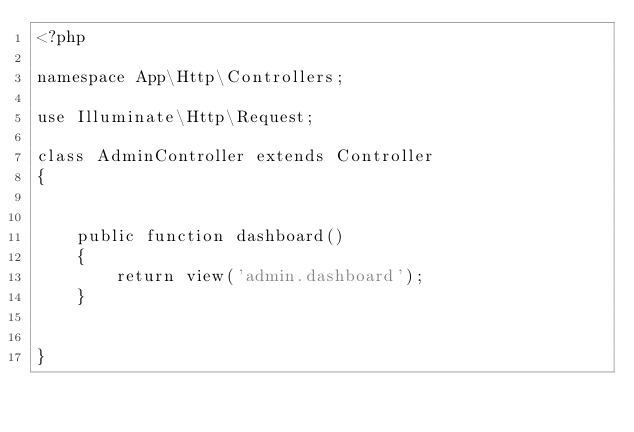<code> <loc_0><loc_0><loc_500><loc_500><_PHP_><?php

namespace App\Http\Controllers;

use Illuminate\Http\Request;

class AdminController extends Controller
{
  

    public function dashboard()
    {
        return view('admin.dashboard');
    }

    
}
</code> 